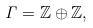Convert formula to latex. <formula><loc_0><loc_0><loc_500><loc_500>\Gamma = \mathbb { Z } \oplus \mathbb { Z } ,</formula> 